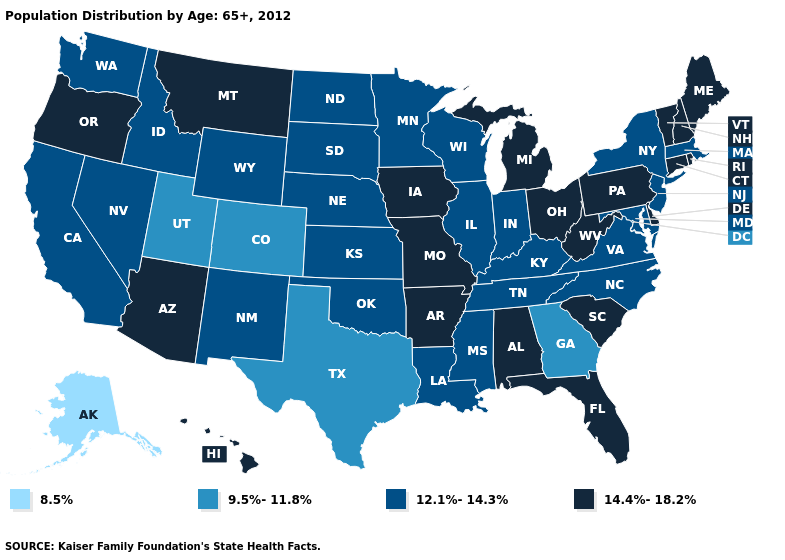Name the states that have a value in the range 14.4%-18.2%?
Be succinct. Alabama, Arizona, Arkansas, Connecticut, Delaware, Florida, Hawaii, Iowa, Maine, Michigan, Missouri, Montana, New Hampshire, Ohio, Oregon, Pennsylvania, Rhode Island, South Carolina, Vermont, West Virginia. Name the states that have a value in the range 8.5%?
Write a very short answer. Alaska. What is the value of Wisconsin?
Give a very brief answer. 12.1%-14.3%. What is the value of Alabama?
Short answer required. 14.4%-18.2%. What is the value of Arizona?
Be succinct. 14.4%-18.2%. Does the first symbol in the legend represent the smallest category?
Quick response, please. Yes. Does West Virginia have the highest value in the South?
Give a very brief answer. Yes. Name the states that have a value in the range 8.5%?
Quick response, please. Alaska. What is the lowest value in states that border Ohio?
Give a very brief answer. 12.1%-14.3%. Does California have a higher value than Idaho?
Be succinct. No. Name the states that have a value in the range 14.4%-18.2%?
Concise answer only. Alabama, Arizona, Arkansas, Connecticut, Delaware, Florida, Hawaii, Iowa, Maine, Michigan, Missouri, Montana, New Hampshire, Ohio, Oregon, Pennsylvania, Rhode Island, South Carolina, Vermont, West Virginia. Name the states that have a value in the range 9.5%-11.8%?
Short answer required. Colorado, Georgia, Texas, Utah. Name the states that have a value in the range 8.5%?
Write a very short answer. Alaska. What is the value of New Jersey?
Be succinct. 12.1%-14.3%. What is the value of Colorado?
Keep it brief. 9.5%-11.8%. 